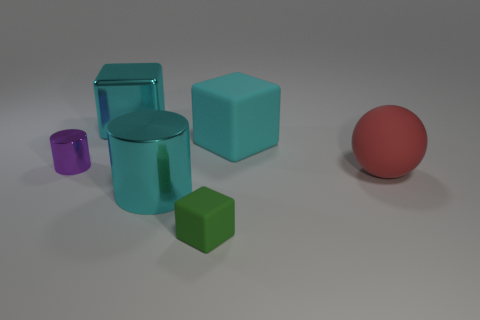What is the color of the big object that is in front of the small metal cylinder and to the left of the red rubber object?
Offer a terse response. Cyan. Is the number of large cylinders that are on the left side of the tiny metallic thing greater than the number of red matte balls that are in front of the green rubber block?
Make the answer very short. No. There is a green block that is the same material as the sphere; what size is it?
Offer a very short reply. Small. How many purple metal objects are behind the matte block that is left of the cyan rubber object?
Provide a short and direct response. 1. Is there a tiny purple metal thing that has the same shape as the red matte object?
Your answer should be very brief. No. What color is the block in front of the rubber block that is behind the large metal cylinder?
Give a very brief answer. Green. Is the number of purple metallic cylinders greater than the number of tiny blue balls?
Keep it short and to the point. Yes. How many purple matte cylinders are the same size as the purple metal thing?
Give a very brief answer. 0. Does the big sphere have the same material as the block that is right of the small rubber object?
Ensure brevity in your answer.  Yes. Are there fewer small green matte things than yellow things?
Offer a very short reply. No. 